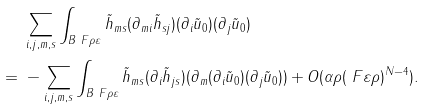Convert formula to latex. <formula><loc_0><loc_0><loc_500><loc_500>& \ \sum _ { i , j , m , s } \int _ { B _ { \ } F { \rho } { \varepsilon } } \tilde { h } _ { m s } ( \partial _ { m i } \tilde { h } _ { s j } ) ( \partial _ { i } \tilde { u } _ { 0 } ) ( \partial _ { j } \tilde { u } _ { 0 } ) \\ = & \ - \sum _ { i , j , m , s } \int _ { B _ { \ } F { \rho } { \varepsilon } } \tilde { h } _ { m s } ( \partial _ { i } \tilde { h } _ { j s } ) ( \partial _ { m } ( \partial _ { i } \tilde { u } _ { 0 } ) ( \partial _ { j } \tilde { u } _ { 0 } ) ) + O ( \alpha \rho ( \ F { \varepsilon } { \rho } ) ^ { N - 4 } ) .</formula> 